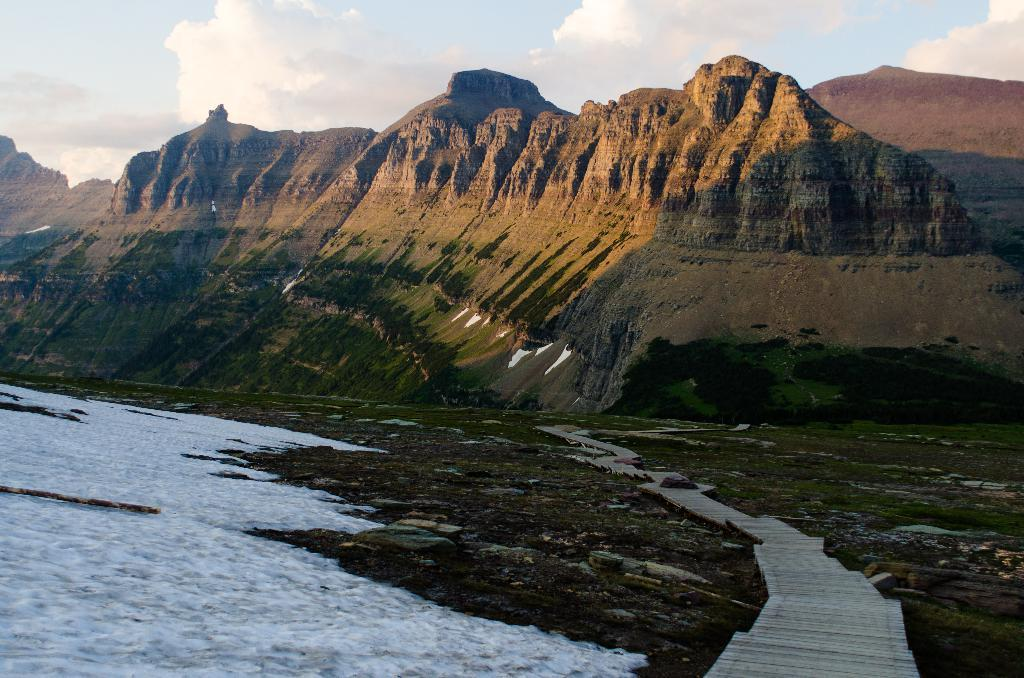What type of structure can be seen in the image? There is a pier in the image. What natural features are visible in the background? Mountains and water are visible in the image. What type of vegetation is present in the image? There is grass in the image. What is the condition of the sky in the image? The sky is cloudy in the image. What color is the pet that is painting the hammer in the image? There is no pet, hammer, or painting activity present in the image. 